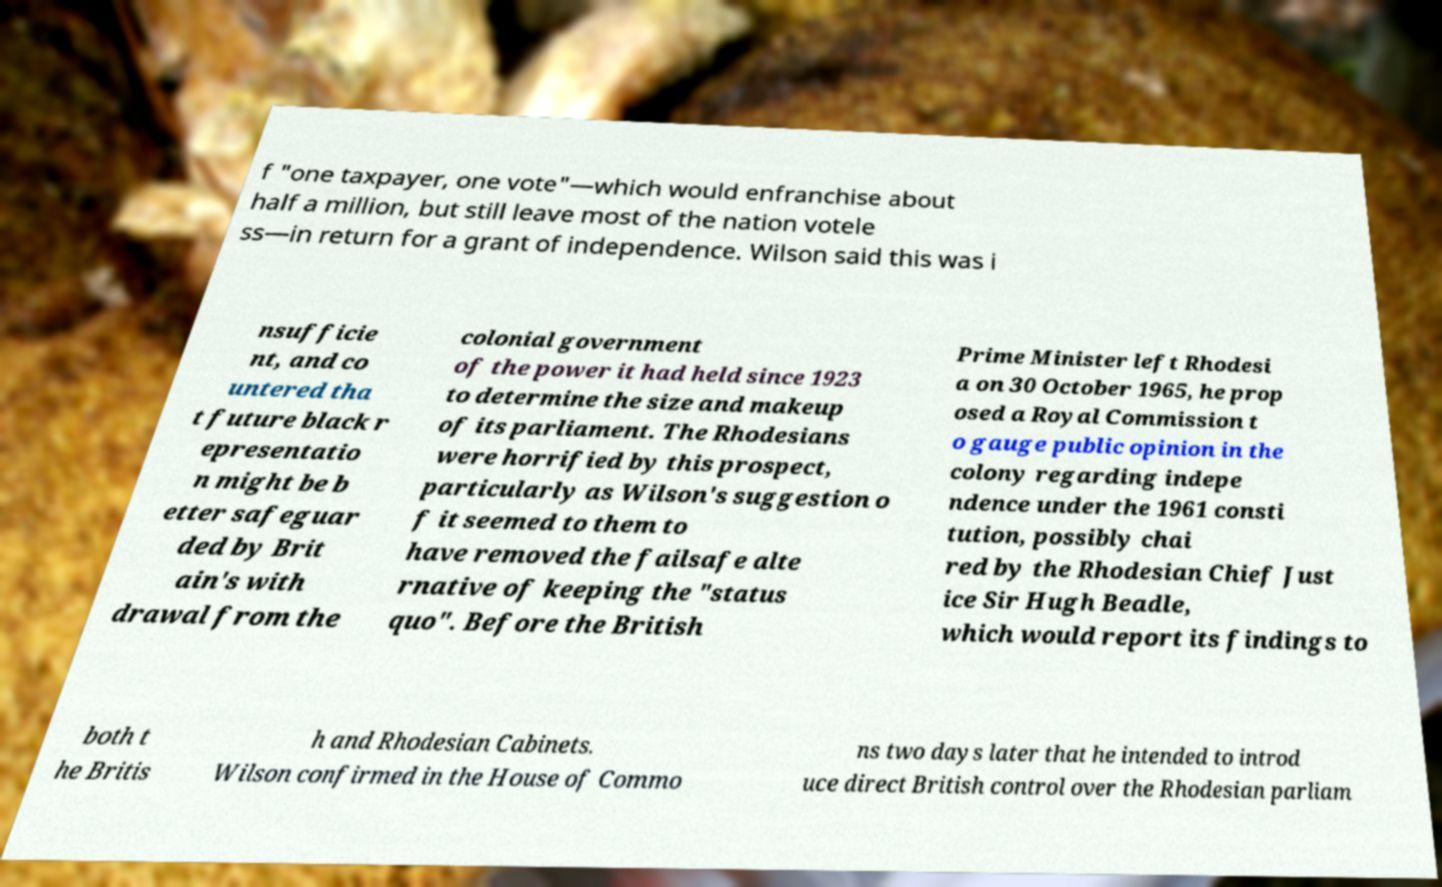Could you extract and type out the text from this image? f "one taxpayer, one vote"—which would enfranchise about half a million, but still leave most of the nation votele ss—in return for a grant of independence. Wilson said this was i nsufficie nt, and co untered tha t future black r epresentatio n might be b etter safeguar ded by Brit ain's with drawal from the colonial government of the power it had held since 1923 to determine the size and makeup of its parliament. The Rhodesians were horrified by this prospect, particularly as Wilson's suggestion o f it seemed to them to have removed the failsafe alte rnative of keeping the "status quo". Before the British Prime Minister left Rhodesi a on 30 October 1965, he prop osed a Royal Commission t o gauge public opinion in the colony regarding indepe ndence under the 1961 consti tution, possibly chai red by the Rhodesian Chief Just ice Sir Hugh Beadle, which would report its findings to both t he Britis h and Rhodesian Cabinets. Wilson confirmed in the House of Commo ns two days later that he intended to introd uce direct British control over the Rhodesian parliam 